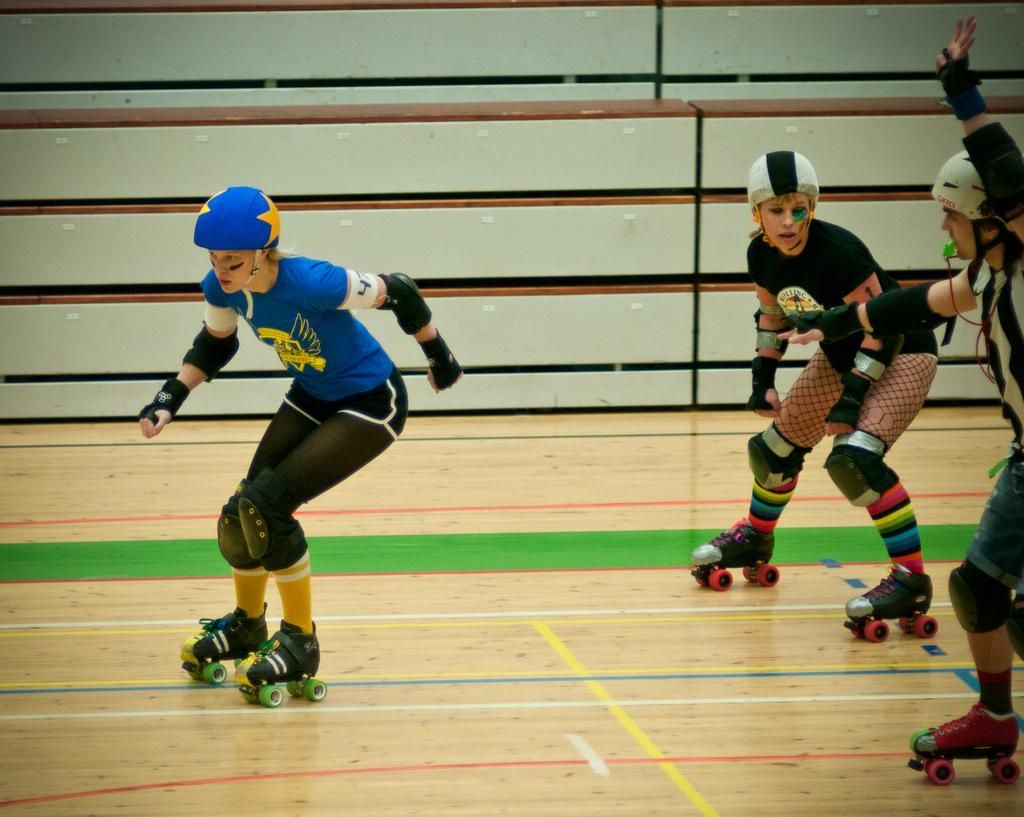What is the surface that the persons are skating on in the image? There is a floor in the image, and the persons are skating on it. What type of protective gear are the persons wearing in the image? The persons are wearing helmets in the image. What type of shoes are the persons wearing for skating? The persons are wearing skating shoes in the image. What can be observed about the background colors in the image? The background of the image has brown, black, and white colors. What is the tendency of the mom to join the skating activity in the image? There is no mention of a mom or any other person in the image besides the ones wearing helmets and skating shoes. 